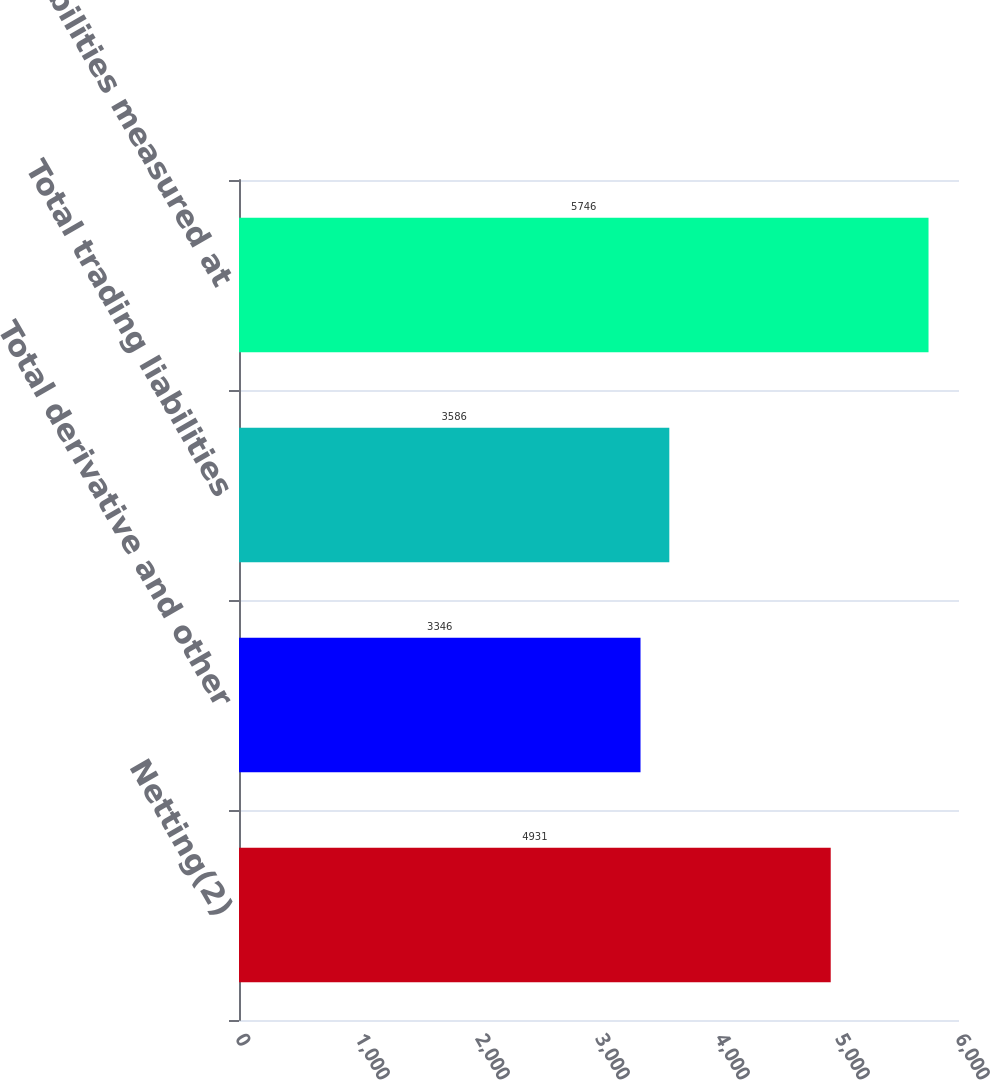<chart> <loc_0><loc_0><loc_500><loc_500><bar_chart><fcel>Netting(2)<fcel>Total derivative and other<fcel>Total trading liabilities<fcel>Total liabilities measured at<nl><fcel>4931<fcel>3346<fcel>3586<fcel>5746<nl></chart> 